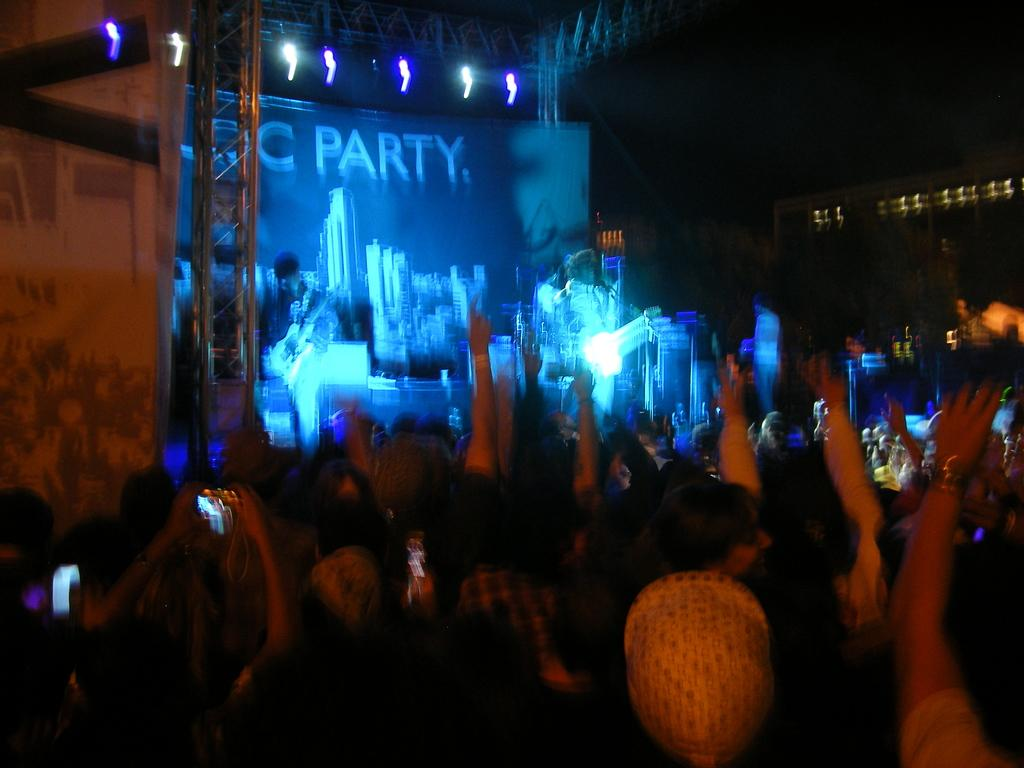How many people are in the image? There is a group of people in the image. Can you describe the background of the image? The background of the image is blurry and dark. What can be seen at the top of the image? There are focusing lights at the top of the image. What type of steel is being used to touch the blood in the image? There is no steel, touch, or blood present in the image. 